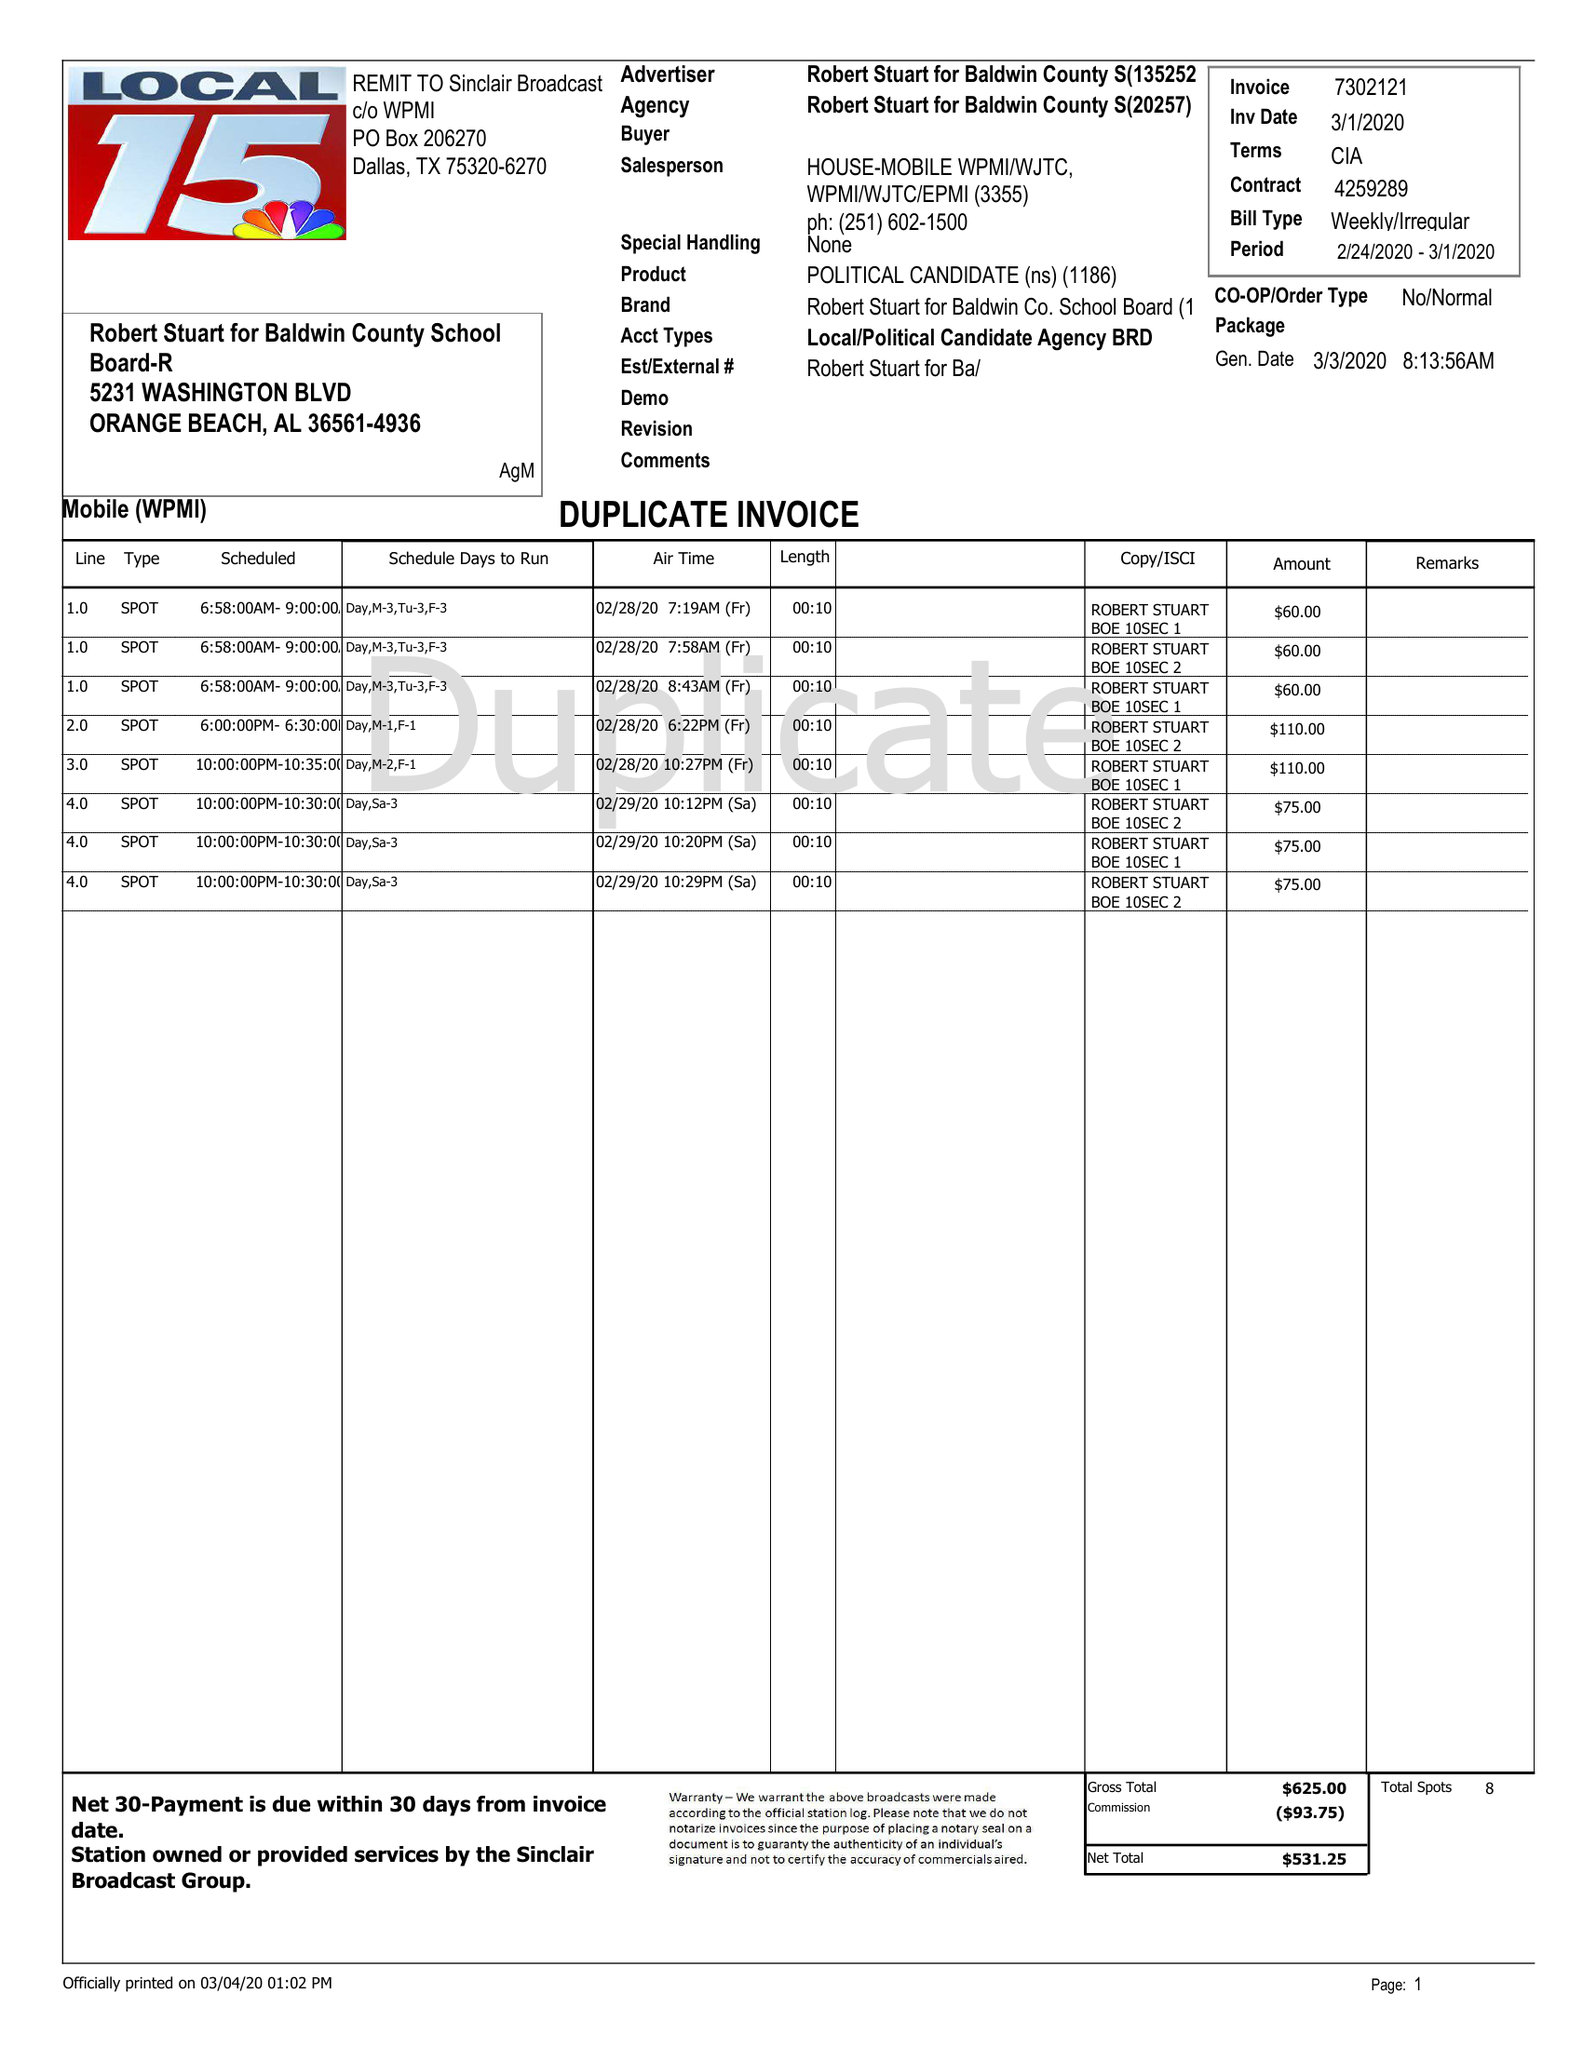What is the value for the flight_to?
Answer the question using a single word or phrase. 03/01/20 